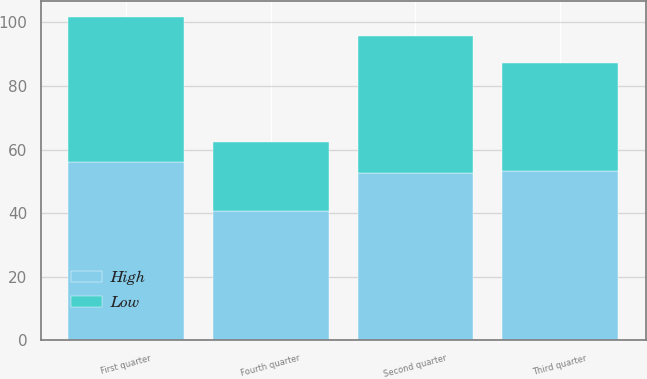Convert chart. <chart><loc_0><loc_0><loc_500><loc_500><stacked_bar_chart><ecel><fcel>First quarter<fcel>Second quarter<fcel>Third quarter<fcel>Fourth quarter<nl><fcel>High<fcel>56.22<fcel>52.68<fcel>53.37<fcel>40.7<nl><fcel>Low<fcel>45.3<fcel>42.93<fcel>33.73<fcel>21.54<nl></chart> 